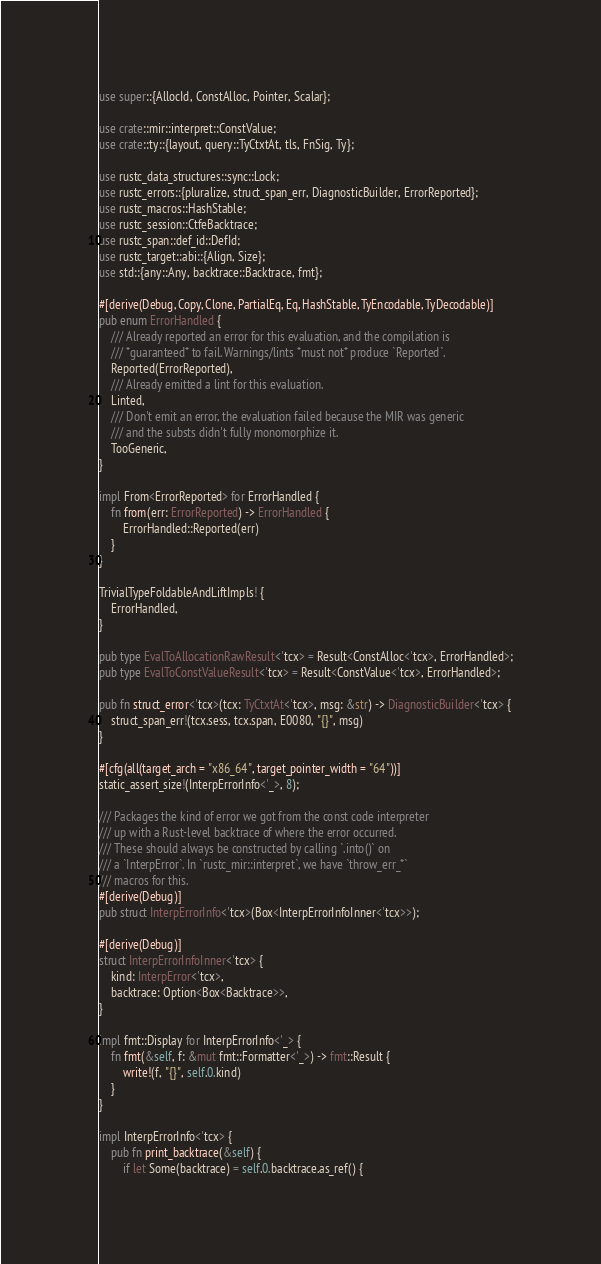<code> <loc_0><loc_0><loc_500><loc_500><_Rust_>use super::{AllocId, ConstAlloc, Pointer, Scalar};

use crate::mir::interpret::ConstValue;
use crate::ty::{layout, query::TyCtxtAt, tls, FnSig, Ty};

use rustc_data_structures::sync::Lock;
use rustc_errors::{pluralize, struct_span_err, DiagnosticBuilder, ErrorReported};
use rustc_macros::HashStable;
use rustc_session::CtfeBacktrace;
use rustc_span::def_id::DefId;
use rustc_target::abi::{Align, Size};
use std::{any::Any, backtrace::Backtrace, fmt};

#[derive(Debug, Copy, Clone, PartialEq, Eq, HashStable, TyEncodable, TyDecodable)]
pub enum ErrorHandled {
    /// Already reported an error for this evaluation, and the compilation is
    /// *guaranteed* to fail. Warnings/lints *must not* produce `Reported`.
    Reported(ErrorReported),
    /// Already emitted a lint for this evaluation.
    Linted,
    /// Don't emit an error, the evaluation failed because the MIR was generic
    /// and the substs didn't fully monomorphize it.
    TooGeneric,
}

impl From<ErrorReported> for ErrorHandled {
    fn from(err: ErrorReported) -> ErrorHandled {
        ErrorHandled::Reported(err)
    }
}

TrivialTypeFoldableAndLiftImpls! {
    ErrorHandled,
}

pub type EvalToAllocationRawResult<'tcx> = Result<ConstAlloc<'tcx>, ErrorHandled>;
pub type EvalToConstValueResult<'tcx> = Result<ConstValue<'tcx>, ErrorHandled>;

pub fn struct_error<'tcx>(tcx: TyCtxtAt<'tcx>, msg: &str) -> DiagnosticBuilder<'tcx> {
    struct_span_err!(tcx.sess, tcx.span, E0080, "{}", msg)
}

#[cfg(all(target_arch = "x86_64", target_pointer_width = "64"))]
static_assert_size!(InterpErrorInfo<'_>, 8);

/// Packages the kind of error we got from the const code interpreter
/// up with a Rust-level backtrace of where the error occurred.
/// These should always be constructed by calling `.into()` on
/// a `InterpError`. In `rustc_mir::interpret`, we have `throw_err_*`
/// macros for this.
#[derive(Debug)]
pub struct InterpErrorInfo<'tcx>(Box<InterpErrorInfoInner<'tcx>>);

#[derive(Debug)]
struct InterpErrorInfoInner<'tcx> {
    kind: InterpError<'tcx>,
    backtrace: Option<Box<Backtrace>>,
}

impl fmt::Display for InterpErrorInfo<'_> {
    fn fmt(&self, f: &mut fmt::Formatter<'_>) -> fmt::Result {
        write!(f, "{}", self.0.kind)
    }
}

impl InterpErrorInfo<'tcx> {
    pub fn print_backtrace(&self) {
        if let Some(backtrace) = self.0.backtrace.as_ref() {</code> 